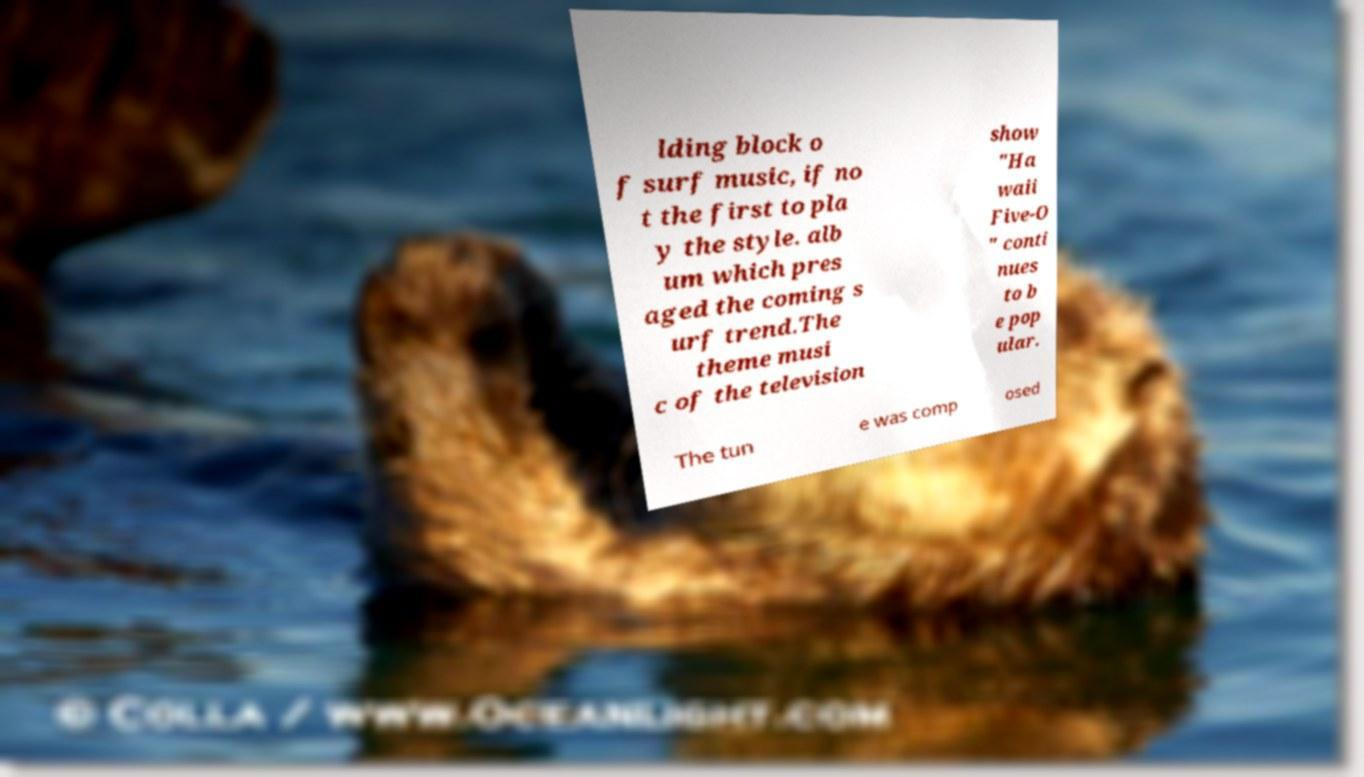Can you read and provide the text displayed in the image?This photo seems to have some interesting text. Can you extract and type it out for me? lding block o f surf music, if no t the first to pla y the style. alb um which pres aged the coming s urf trend.The theme musi c of the television show "Ha waii Five-O " conti nues to b e pop ular. The tun e was comp osed 